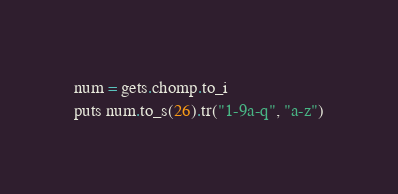Convert code to text. <code><loc_0><loc_0><loc_500><loc_500><_Ruby_>num = gets.chomp.to_i
puts num.to_s(26).tr("1-9a-q", "a-z")
</code> 